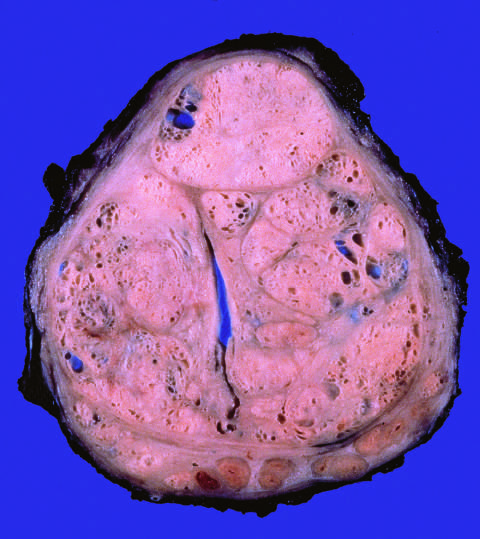do the histone subunits compress the urethra into a slitlike lumen?
Answer the question using a single word or phrase. No 